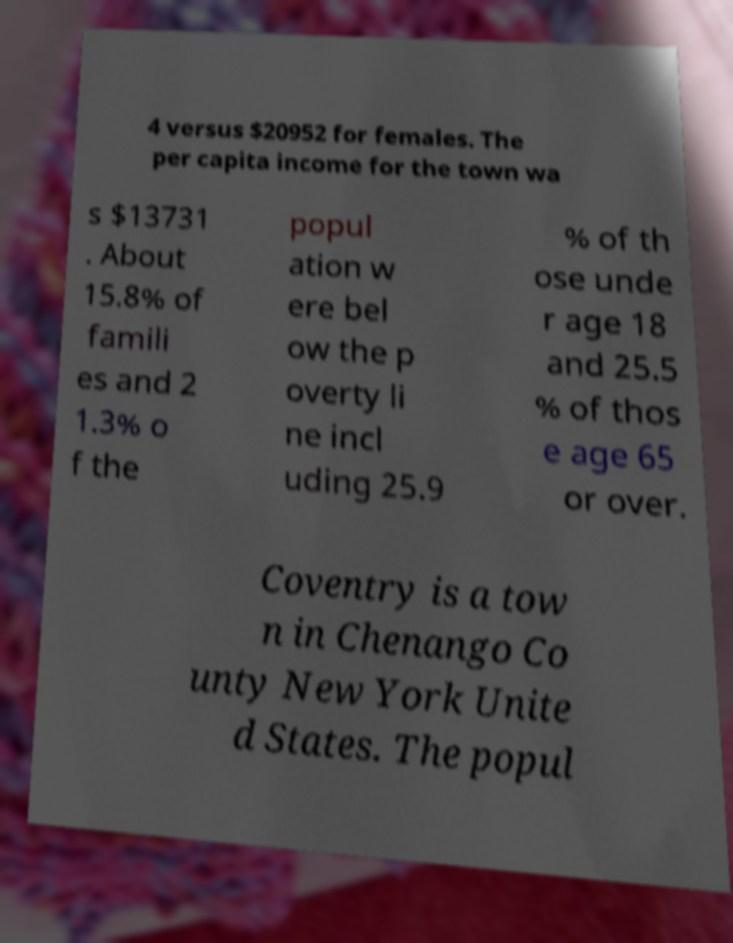Please identify and transcribe the text found in this image. 4 versus $20952 for females. The per capita income for the town wa s $13731 . About 15.8% of famili es and 2 1.3% o f the popul ation w ere bel ow the p overty li ne incl uding 25.9 % of th ose unde r age 18 and 25.5 % of thos e age 65 or over. Coventry is a tow n in Chenango Co unty New York Unite d States. The popul 